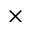<formula> <loc_0><loc_0><loc_500><loc_500>\times</formula> 